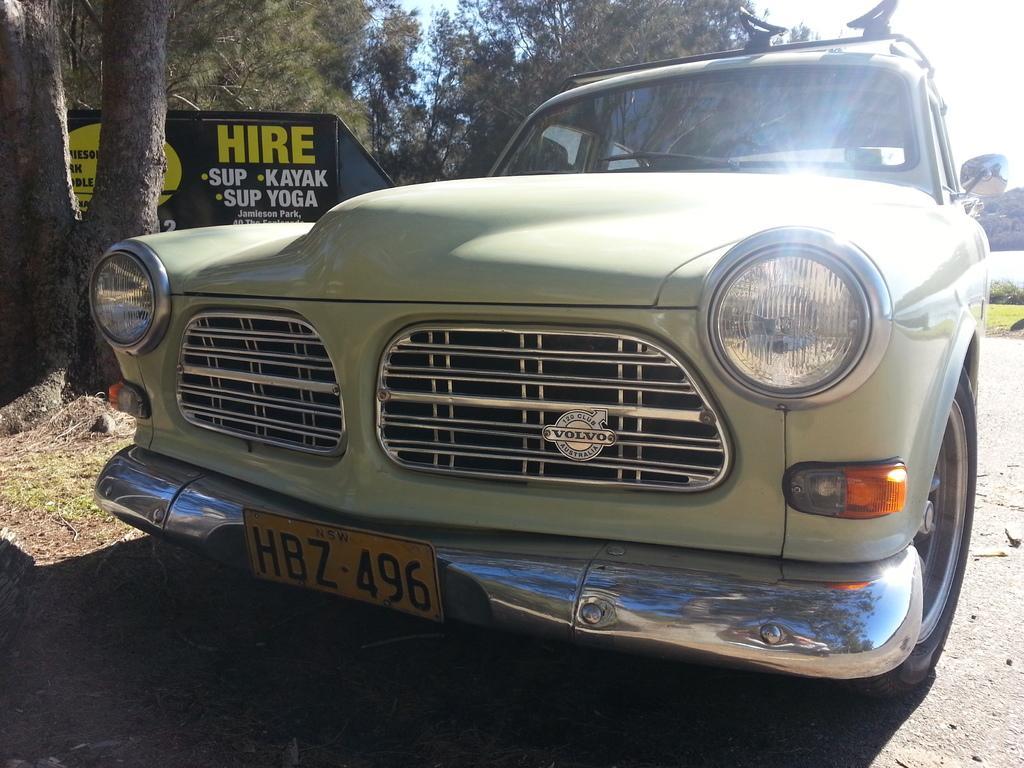How would you summarize this image in a sentence or two? In this image I can see the vehicle to the side of the road. I can see the yellow color number plate to it. To the left there is a black color board and something is written on it. In the back I can see many trees and the white sky. 